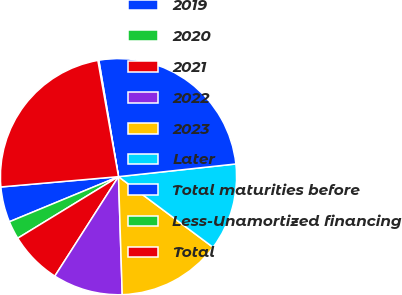Convert chart to OTSL. <chart><loc_0><loc_0><loc_500><loc_500><pie_chart><fcel>2019<fcel>2020<fcel>2021<fcel>2022<fcel>2023<fcel>Later<fcel>Total maturities before<fcel>Less-Unamortized financing<fcel>Total<nl><fcel>4.85%<fcel>2.49%<fcel>7.21%<fcel>9.57%<fcel>14.29%<fcel>11.93%<fcel>25.96%<fcel>0.13%<fcel>23.6%<nl></chart> 